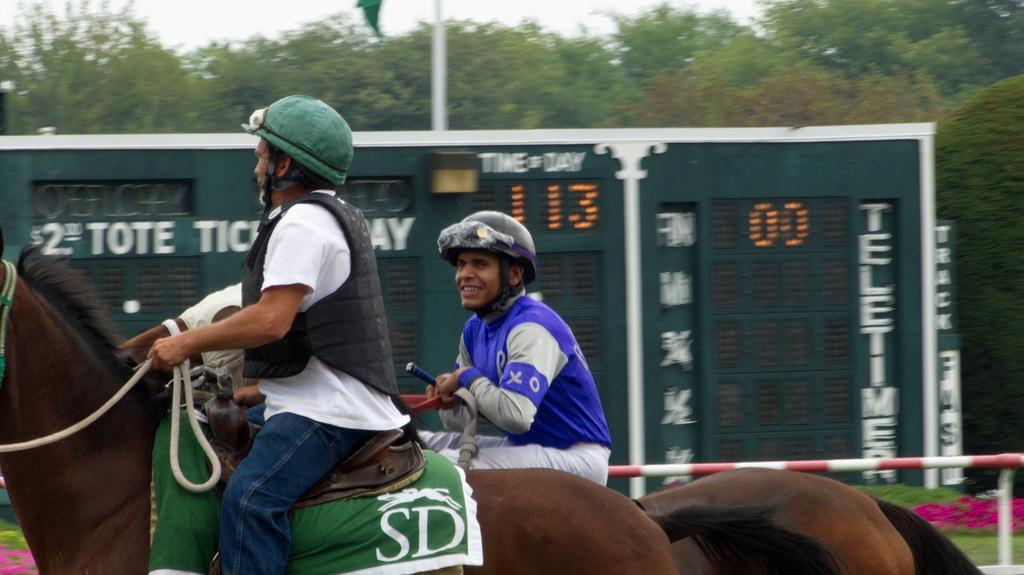In one or two sentences, can you explain what this image depicts? In this image there are two people riding horses, in the background there is a score board, trees and the sky. 